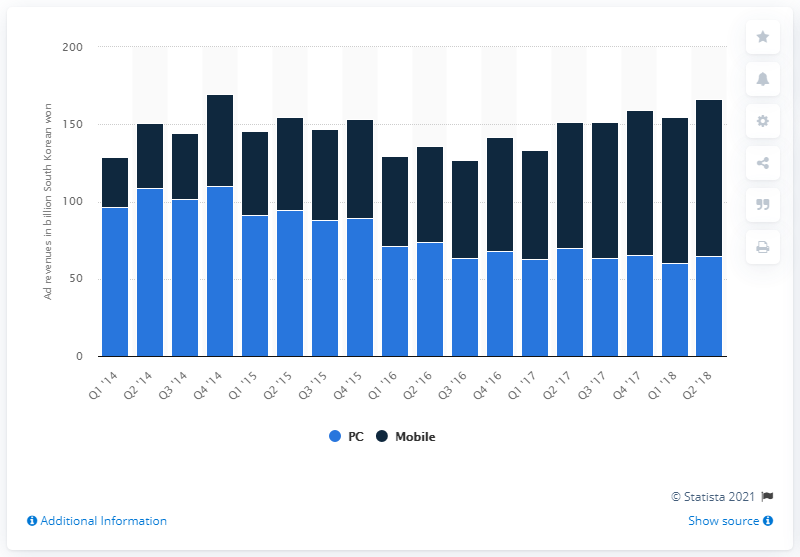Identify some key points in this picture. Kakao's mobile advertising revenue in the second quarter of 2018 was 101.49 million. 